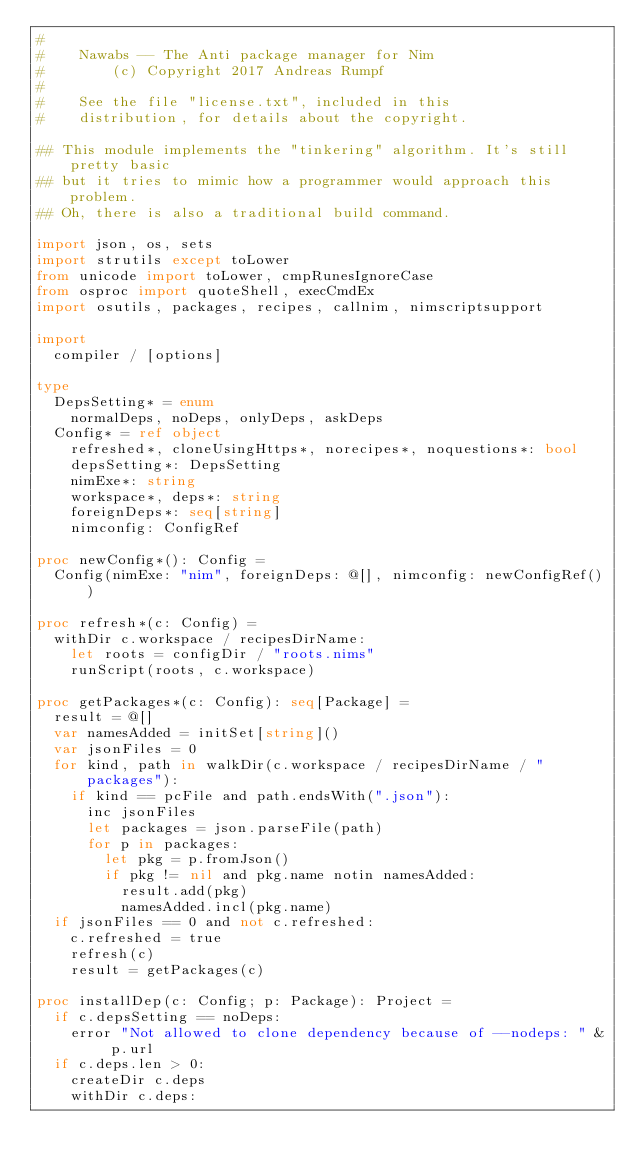<code> <loc_0><loc_0><loc_500><loc_500><_Nim_>#
#    Nawabs -- The Anti package manager for Nim
#        (c) Copyright 2017 Andreas Rumpf
#
#    See the file "license.txt", included in this
#    distribution, for details about the copyright.

## This module implements the "tinkering" algorithm. It's still pretty basic
## but it tries to mimic how a programmer would approach this problem.
## Oh, there is also a traditional build command.

import json, os, sets
import strutils except toLower
from unicode import toLower, cmpRunesIgnoreCase
from osproc import quoteShell, execCmdEx
import osutils, packages, recipes, callnim, nimscriptsupport

import
  compiler / [options]

type
  DepsSetting* = enum
    normalDeps, noDeps, onlyDeps, askDeps
  Config* = ref object
    refreshed*, cloneUsingHttps*, norecipes*, noquestions*: bool
    depsSetting*: DepsSetting
    nimExe*: string
    workspace*, deps*: string
    foreignDeps*: seq[string]
    nimconfig: ConfigRef

proc newConfig*(): Config =
  Config(nimExe: "nim", foreignDeps: @[], nimconfig: newConfigRef())

proc refresh*(c: Config) =
  withDir c.workspace / recipesDirName:
    let roots = configDir / "roots.nims"
    runScript(roots, c.workspace)

proc getPackages*(c: Config): seq[Package] =
  result = @[]
  var namesAdded = initSet[string]()
  var jsonFiles = 0
  for kind, path in walkDir(c.workspace / recipesDirName / "packages"):
    if kind == pcFile and path.endsWith(".json"):
      inc jsonFiles
      let packages = json.parseFile(path)
      for p in packages:
        let pkg = p.fromJson()
        if pkg != nil and pkg.name notin namesAdded:
          result.add(pkg)
          namesAdded.incl(pkg.name)
  if jsonFiles == 0 and not c.refreshed:
    c.refreshed = true
    refresh(c)
    result = getPackages(c)

proc installDep(c: Config; p: Package): Project =
  if c.depsSetting == noDeps:
    error "Not allowed to clone dependency because of --nodeps: " & p.url
  if c.deps.len > 0:
    createDir c.deps
    withDir c.deps:</code> 